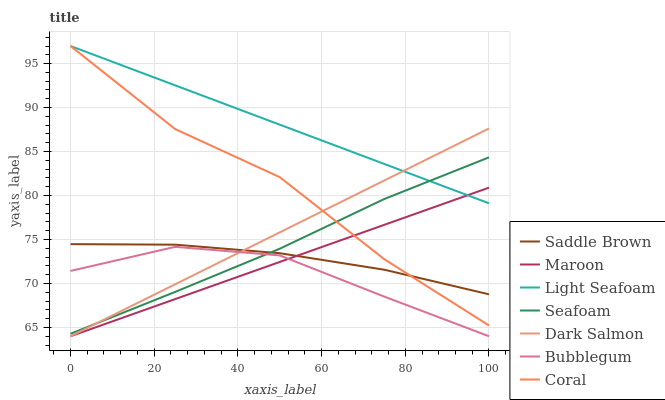Does Bubblegum have the minimum area under the curve?
Answer yes or no. Yes. Does Light Seafoam have the maximum area under the curve?
Answer yes or no. Yes. Does Dark Salmon have the minimum area under the curve?
Answer yes or no. No. Does Dark Salmon have the maximum area under the curve?
Answer yes or no. No. Is Dark Salmon the smoothest?
Answer yes or no. Yes. Is Coral the roughest?
Answer yes or no. Yes. Is Bubblegum the smoothest?
Answer yes or no. No. Is Bubblegum the roughest?
Answer yes or no. No. Does Dark Salmon have the lowest value?
Answer yes or no. Yes. Does Seafoam have the lowest value?
Answer yes or no. No. Does Light Seafoam have the highest value?
Answer yes or no. Yes. Does Dark Salmon have the highest value?
Answer yes or no. No. Is Bubblegum less than Coral?
Answer yes or no. Yes. Is Seafoam greater than Maroon?
Answer yes or no. Yes. Does Coral intersect Dark Salmon?
Answer yes or no. Yes. Is Coral less than Dark Salmon?
Answer yes or no. No. Is Coral greater than Dark Salmon?
Answer yes or no. No. Does Bubblegum intersect Coral?
Answer yes or no. No. 